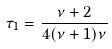Convert formula to latex. <formula><loc_0><loc_0><loc_500><loc_500>\tau _ { 1 } = \frac { \nu + 2 } { 4 ( \nu + 1 ) \nu }</formula> 